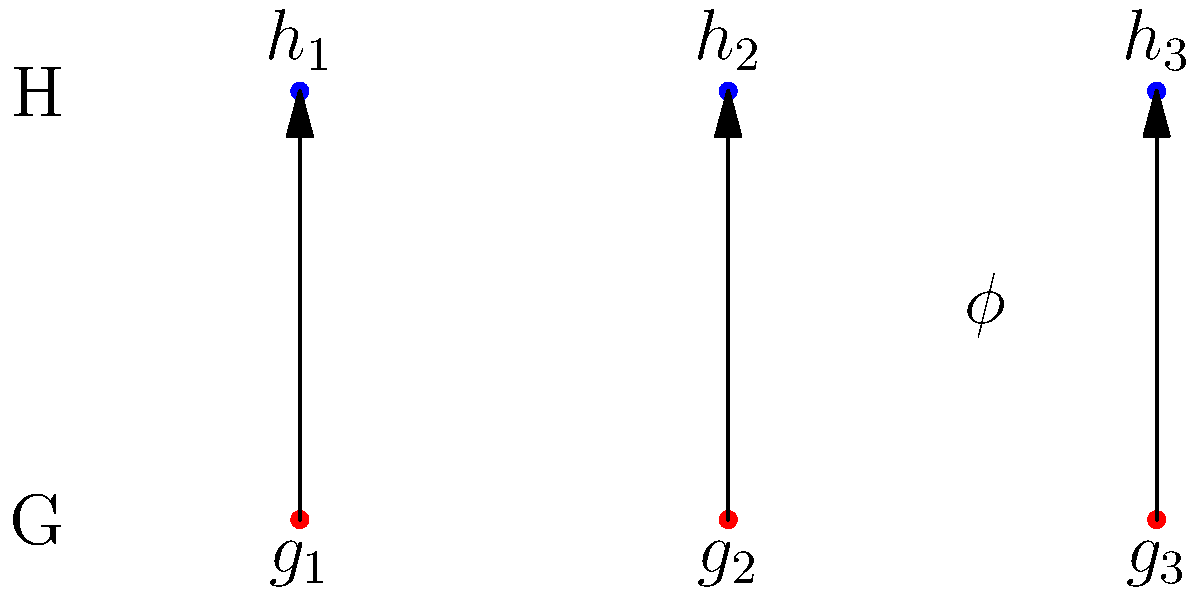In the arrow diagram above, a homomorphism $\phi$ is shown between two groups $G$ and $H$. Both groups have three elements. If $g_1$ is the identity element of $G$ and $\phi(g_2g_3) = h_2$, what can you conclude about $\phi(g_2)$ and $\phi(g_3)$? Explain your reasoning using the properties of group homomorphisms. Let's approach this step-by-step:

1) First, recall the definition of a group homomorphism: For all $a, b \in G$, $\phi(ab) = \phi(a)\phi(b)$.

2) We're given that $\phi(g_2g_3) = h_2$.

3) By the homomorphism property, we can write: $\phi(g_2g_3) = \phi(g_2)\phi(g_3) = h_2$.

4) Now, let's consider the possible values for $\phi(g_2)$ and $\phi(g_3)$:
   - They can't both be $h_1$, as $h_1h_1 = h_1$ (since $h_1$ must be the identity in $H$).
   - They can't both be $h_3$, as $h_3h_3$ would equal $h_1$ in a group of order 3.
   - The only possibility that satisfies $\phi(g_2)\phi(g_3) = h_2$ is if one of $\phi(g_2)$ or $\phi(g_3)$ is $h_2$, and the other is $h_1$.

5) We can't determine which is which based on the given information.

6) However, we know that $g_1$ is the identity in $G$, so $\phi(g_1)$ must be the identity in $H$, which is $h_1$.

Therefore, we can conclude that one of $\phi(g_2)$ or $\phi(g_3)$ must be $h_2$, and the other must be $h_1$.
Answer: $\phi(g_2) = h_2$ and $\phi(g_3) = h_1$, or vice versa. 